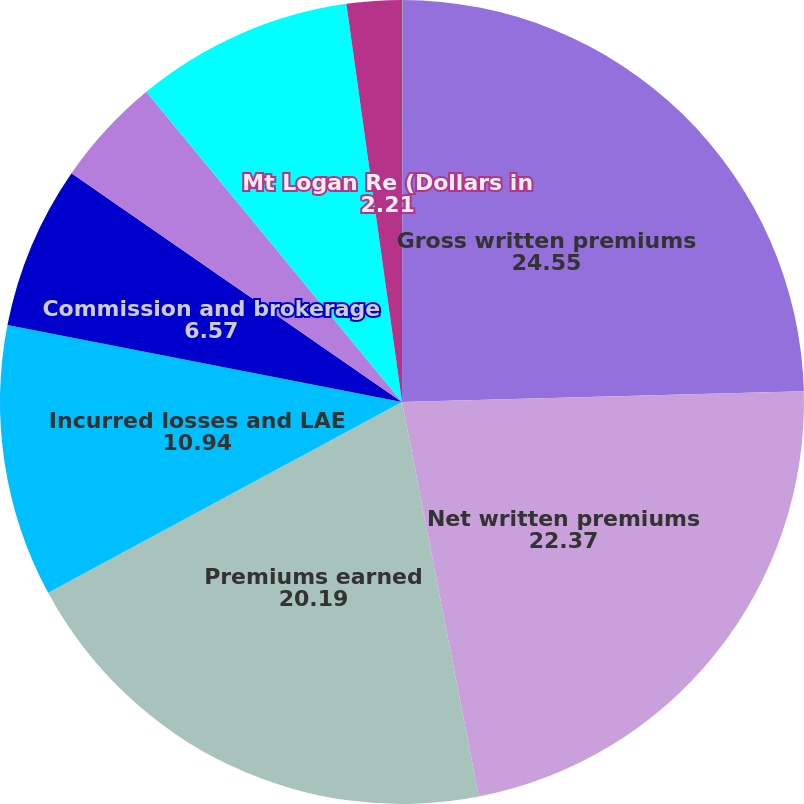Convert chart to OTSL. <chart><loc_0><loc_0><loc_500><loc_500><pie_chart><fcel>(Dollars in thousands)<fcel>Gross written premiums<fcel>Net written premiums<fcel>Premiums earned<fcel>Incurred losses and LAE<fcel>Commission and brokerage<fcel>Other underwriting expenses<fcel>Underwriting gain (loss)<fcel>Mt Logan Re (Dollars in<nl><fcel>0.02%<fcel>24.55%<fcel>22.37%<fcel>20.19%<fcel>10.94%<fcel>6.57%<fcel>4.39%<fcel>8.76%<fcel>2.21%<nl></chart> 